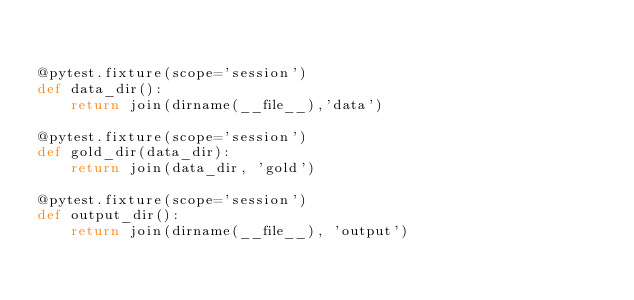Convert code to text. <code><loc_0><loc_0><loc_500><loc_500><_Python_>

@pytest.fixture(scope='session')
def data_dir():
    return join(dirname(__file__),'data')

@pytest.fixture(scope='session')
def gold_dir(data_dir):
    return join(data_dir, 'gold')

@pytest.fixture(scope='session')
def output_dir():
    return join(dirname(__file__), 'output')
</code> 